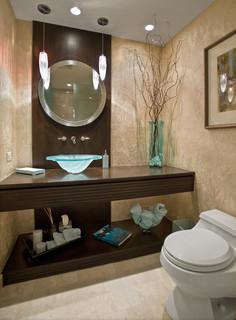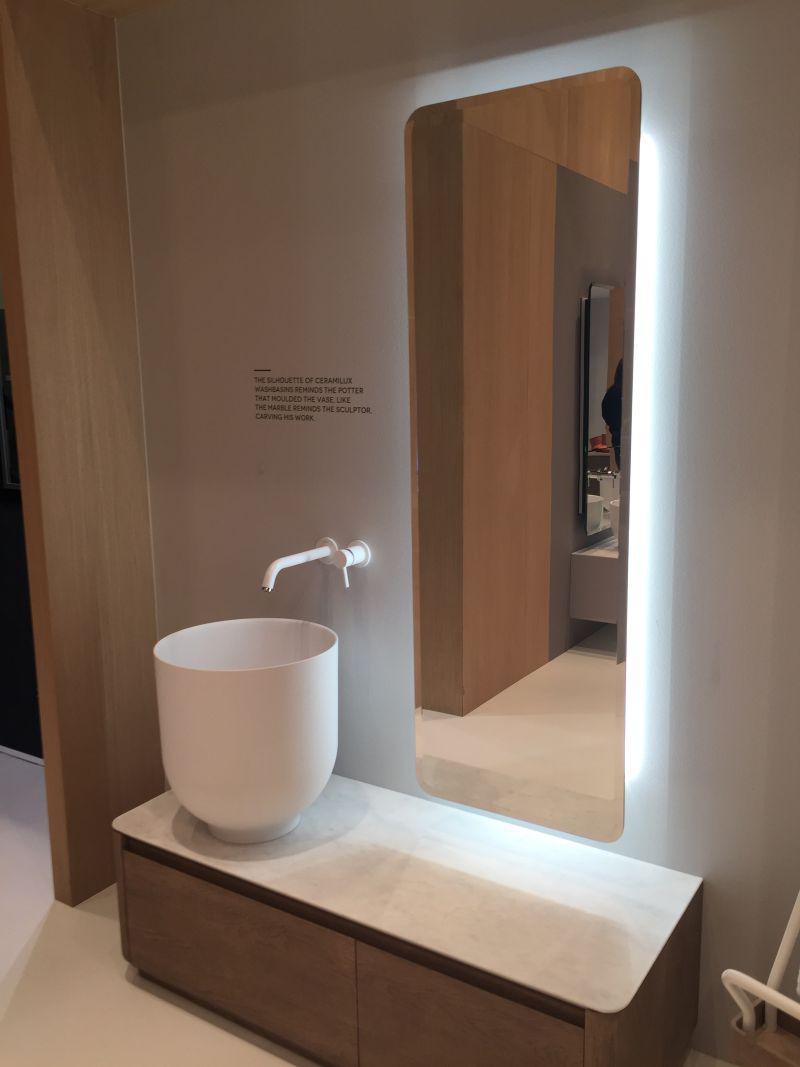The first image is the image on the left, the second image is the image on the right. For the images displayed, is the sentence "Three faucets are attached directly to the sink porcelain." factually correct? Answer yes or no. No. The first image is the image on the left, the second image is the image on the right. Evaluate the accuracy of this statement regarding the images: "In total, three sink basins are shown.". Is it true? Answer yes or no. No. 